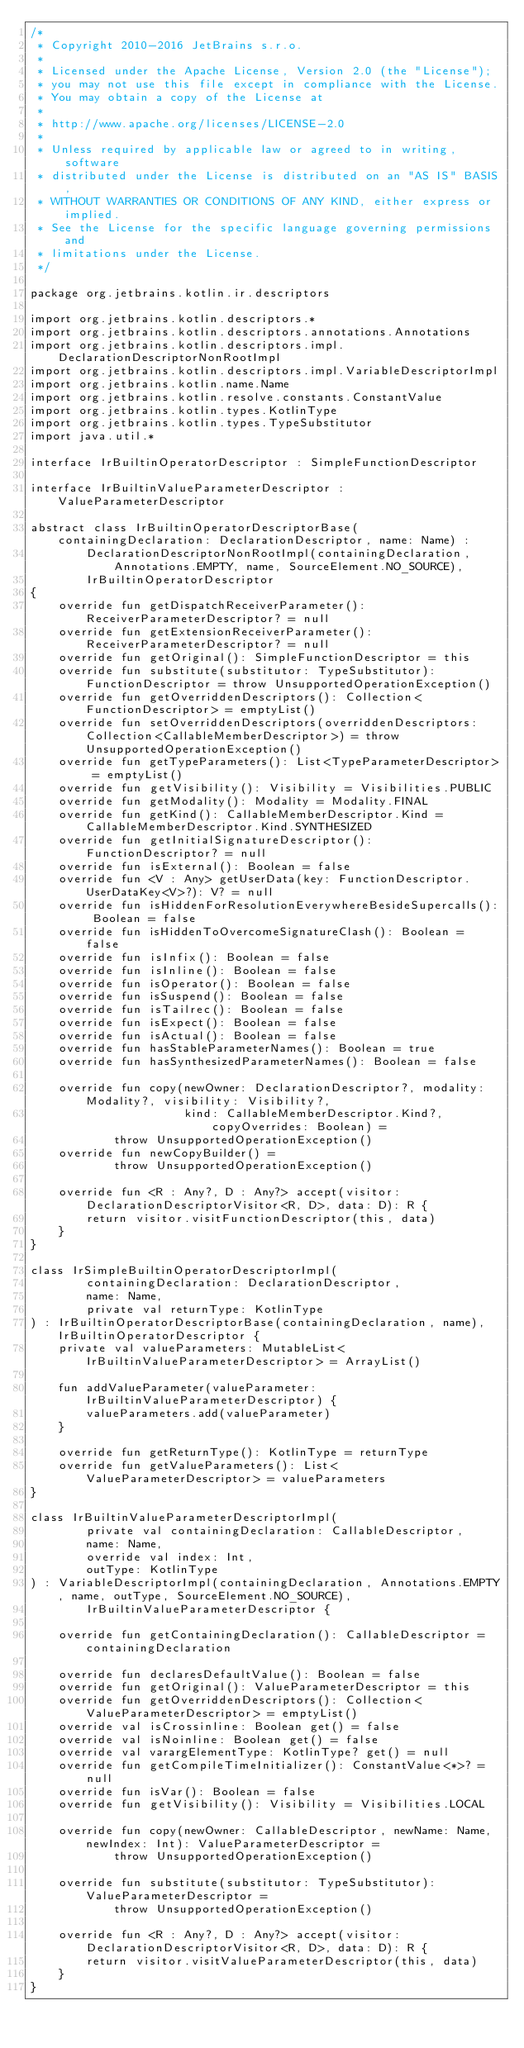<code> <loc_0><loc_0><loc_500><loc_500><_Kotlin_>/*
 * Copyright 2010-2016 JetBrains s.r.o.
 *
 * Licensed under the Apache License, Version 2.0 (the "License");
 * you may not use this file except in compliance with the License.
 * You may obtain a copy of the License at
 *
 * http://www.apache.org/licenses/LICENSE-2.0
 *
 * Unless required by applicable law or agreed to in writing, software
 * distributed under the License is distributed on an "AS IS" BASIS,
 * WITHOUT WARRANTIES OR CONDITIONS OF ANY KIND, either express or implied.
 * See the License for the specific language governing permissions and
 * limitations under the License.
 */

package org.jetbrains.kotlin.ir.descriptors

import org.jetbrains.kotlin.descriptors.*
import org.jetbrains.kotlin.descriptors.annotations.Annotations
import org.jetbrains.kotlin.descriptors.impl.DeclarationDescriptorNonRootImpl
import org.jetbrains.kotlin.descriptors.impl.VariableDescriptorImpl
import org.jetbrains.kotlin.name.Name
import org.jetbrains.kotlin.resolve.constants.ConstantValue
import org.jetbrains.kotlin.types.KotlinType
import org.jetbrains.kotlin.types.TypeSubstitutor
import java.util.*

interface IrBuiltinOperatorDescriptor : SimpleFunctionDescriptor

interface IrBuiltinValueParameterDescriptor : ValueParameterDescriptor

abstract class IrBuiltinOperatorDescriptorBase(containingDeclaration: DeclarationDescriptor, name: Name) :
        DeclarationDescriptorNonRootImpl(containingDeclaration, Annotations.EMPTY, name, SourceElement.NO_SOURCE),
        IrBuiltinOperatorDescriptor
{
    override fun getDispatchReceiverParameter(): ReceiverParameterDescriptor? = null
    override fun getExtensionReceiverParameter(): ReceiverParameterDescriptor? = null
    override fun getOriginal(): SimpleFunctionDescriptor = this
    override fun substitute(substitutor: TypeSubstitutor): FunctionDescriptor = throw UnsupportedOperationException()
    override fun getOverriddenDescriptors(): Collection<FunctionDescriptor> = emptyList()
    override fun setOverriddenDescriptors(overriddenDescriptors: Collection<CallableMemberDescriptor>) = throw UnsupportedOperationException()
    override fun getTypeParameters(): List<TypeParameterDescriptor> = emptyList()
    override fun getVisibility(): Visibility = Visibilities.PUBLIC
    override fun getModality(): Modality = Modality.FINAL
    override fun getKind(): CallableMemberDescriptor.Kind = CallableMemberDescriptor.Kind.SYNTHESIZED
    override fun getInitialSignatureDescriptor(): FunctionDescriptor? = null
    override fun isExternal(): Boolean = false
    override fun <V : Any> getUserData(key: FunctionDescriptor.UserDataKey<V>?): V? = null
    override fun isHiddenForResolutionEverywhereBesideSupercalls(): Boolean = false
    override fun isHiddenToOvercomeSignatureClash(): Boolean = false
    override fun isInfix(): Boolean = false
    override fun isInline(): Boolean = false
    override fun isOperator(): Boolean = false
    override fun isSuspend(): Boolean = false
    override fun isTailrec(): Boolean = false
    override fun isExpect(): Boolean = false
    override fun isActual(): Boolean = false
    override fun hasStableParameterNames(): Boolean = true
    override fun hasSynthesizedParameterNames(): Boolean = false

    override fun copy(newOwner: DeclarationDescriptor?, modality: Modality?, visibility: Visibility?,
                      kind: CallableMemberDescriptor.Kind?, copyOverrides: Boolean) =
            throw UnsupportedOperationException()
    override fun newCopyBuilder() =
            throw UnsupportedOperationException()

    override fun <R : Any?, D : Any?> accept(visitor: DeclarationDescriptorVisitor<R, D>, data: D): R {
        return visitor.visitFunctionDescriptor(this, data)
    }
}

class IrSimpleBuiltinOperatorDescriptorImpl(
        containingDeclaration: DeclarationDescriptor,
        name: Name,
        private val returnType: KotlinType
) : IrBuiltinOperatorDescriptorBase(containingDeclaration, name), IrBuiltinOperatorDescriptor {
    private val valueParameters: MutableList<IrBuiltinValueParameterDescriptor> = ArrayList()

    fun addValueParameter(valueParameter: IrBuiltinValueParameterDescriptor) {
        valueParameters.add(valueParameter)
    }

    override fun getReturnType(): KotlinType = returnType
    override fun getValueParameters(): List<ValueParameterDescriptor> = valueParameters
}

class IrBuiltinValueParameterDescriptorImpl(
        private val containingDeclaration: CallableDescriptor,
        name: Name,
        override val index: Int,
        outType: KotlinType
) : VariableDescriptorImpl(containingDeclaration, Annotations.EMPTY, name, outType, SourceElement.NO_SOURCE),
        IrBuiltinValueParameterDescriptor {

    override fun getContainingDeclaration(): CallableDescriptor = containingDeclaration

    override fun declaresDefaultValue(): Boolean = false
    override fun getOriginal(): ValueParameterDescriptor = this
    override fun getOverriddenDescriptors(): Collection<ValueParameterDescriptor> = emptyList()
    override val isCrossinline: Boolean get() = false
    override val isNoinline: Boolean get() = false
    override val varargElementType: KotlinType? get() = null
    override fun getCompileTimeInitializer(): ConstantValue<*>? = null
    override fun isVar(): Boolean = false
    override fun getVisibility(): Visibility = Visibilities.LOCAL

    override fun copy(newOwner: CallableDescriptor, newName: Name, newIndex: Int): ValueParameterDescriptor =
            throw UnsupportedOperationException()

    override fun substitute(substitutor: TypeSubstitutor): ValueParameterDescriptor =
            throw UnsupportedOperationException()

    override fun <R : Any?, D : Any?> accept(visitor: DeclarationDescriptorVisitor<R, D>, data: D): R {
        return visitor.visitValueParameterDescriptor(this, data)
    }
}</code> 